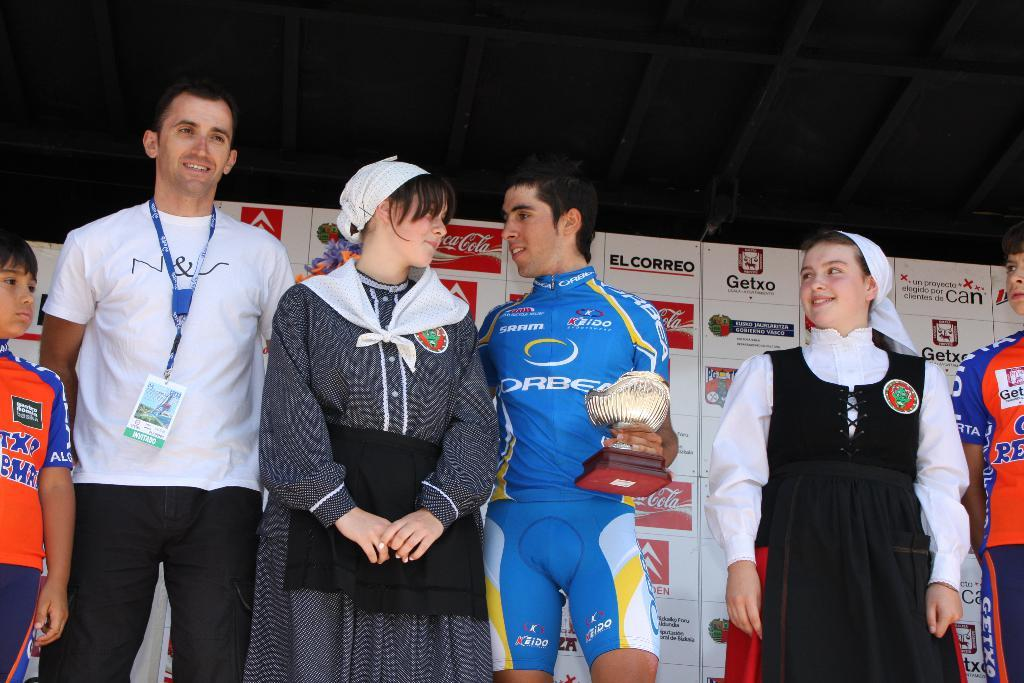<image>
Share a concise interpretation of the image provided. A winner is presented with a trophy on stage wearing a keido sportswear sponsored jersey. 